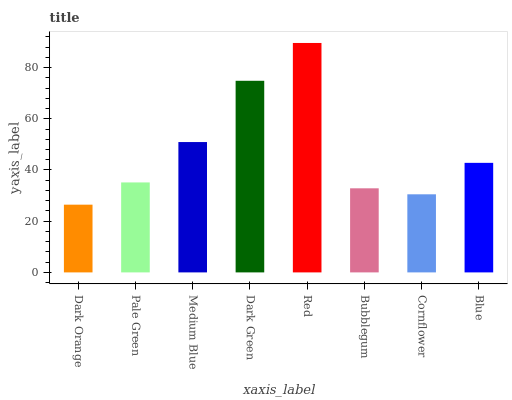Is Dark Orange the minimum?
Answer yes or no. Yes. Is Red the maximum?
Answer yes or no. Yes. Is Pale Green the minimum?
Answer yes or no. No. Is Pale Green the maximum?
Answer yes or no. No. Is Pale Green greater than Dark Orange?
Answer yes or no. Yes. Is Dark Orange less than Pale Green?
Answer yes or no. Yes. Is Dark Orange greater than Pale Green?
Answer yes or no. No. Is Pale Green less than Dark Orange?
Answer yes or no. No. Is Blue the high median?
Answer yes or no. Yes. Is Pale Green the low median?
Answer yes or no. Yes. Is Red the high median?
Answer yes or no. No. Is Dark Green the low median?
Answer yes or no. No. 